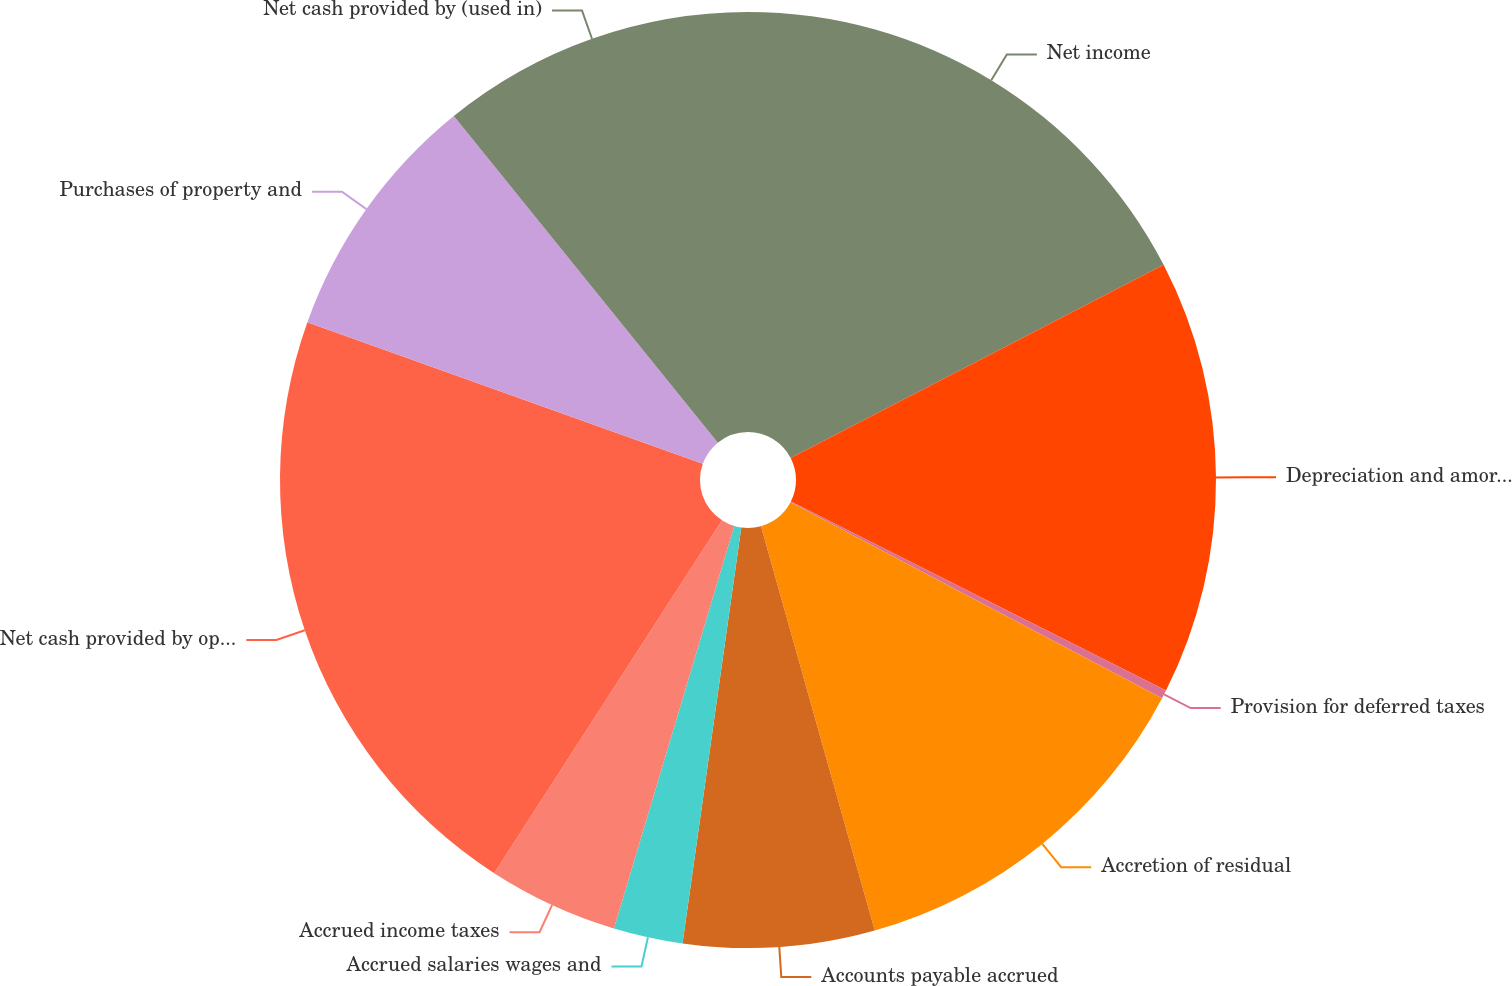Convert chart to OTSL. <chart><loc_0><loc_0><loc_500><loc_500><pie_chart><fcel>Net income<fcel>Depreciation and amortization<fcel>Provision for deferred taxes<fcel>Accretion of residual<fcel>Accounts payable accrued<fcel>Accrued salaries wages and<fcel>Accrued income taxes<fcel>Net cash provided by operating<fcel>Purchases of property and<fcel>Net cash provided by (used in)<nl><fcel>17.4%<fcel>15.03%<fcel>0.29%<fcel>12.92%<fcel>6.6%<fcel>2.39%<fcel>4.5%<fcel>21.35%<fcel>8.71%<fcel>10.82%<nl></chart> 